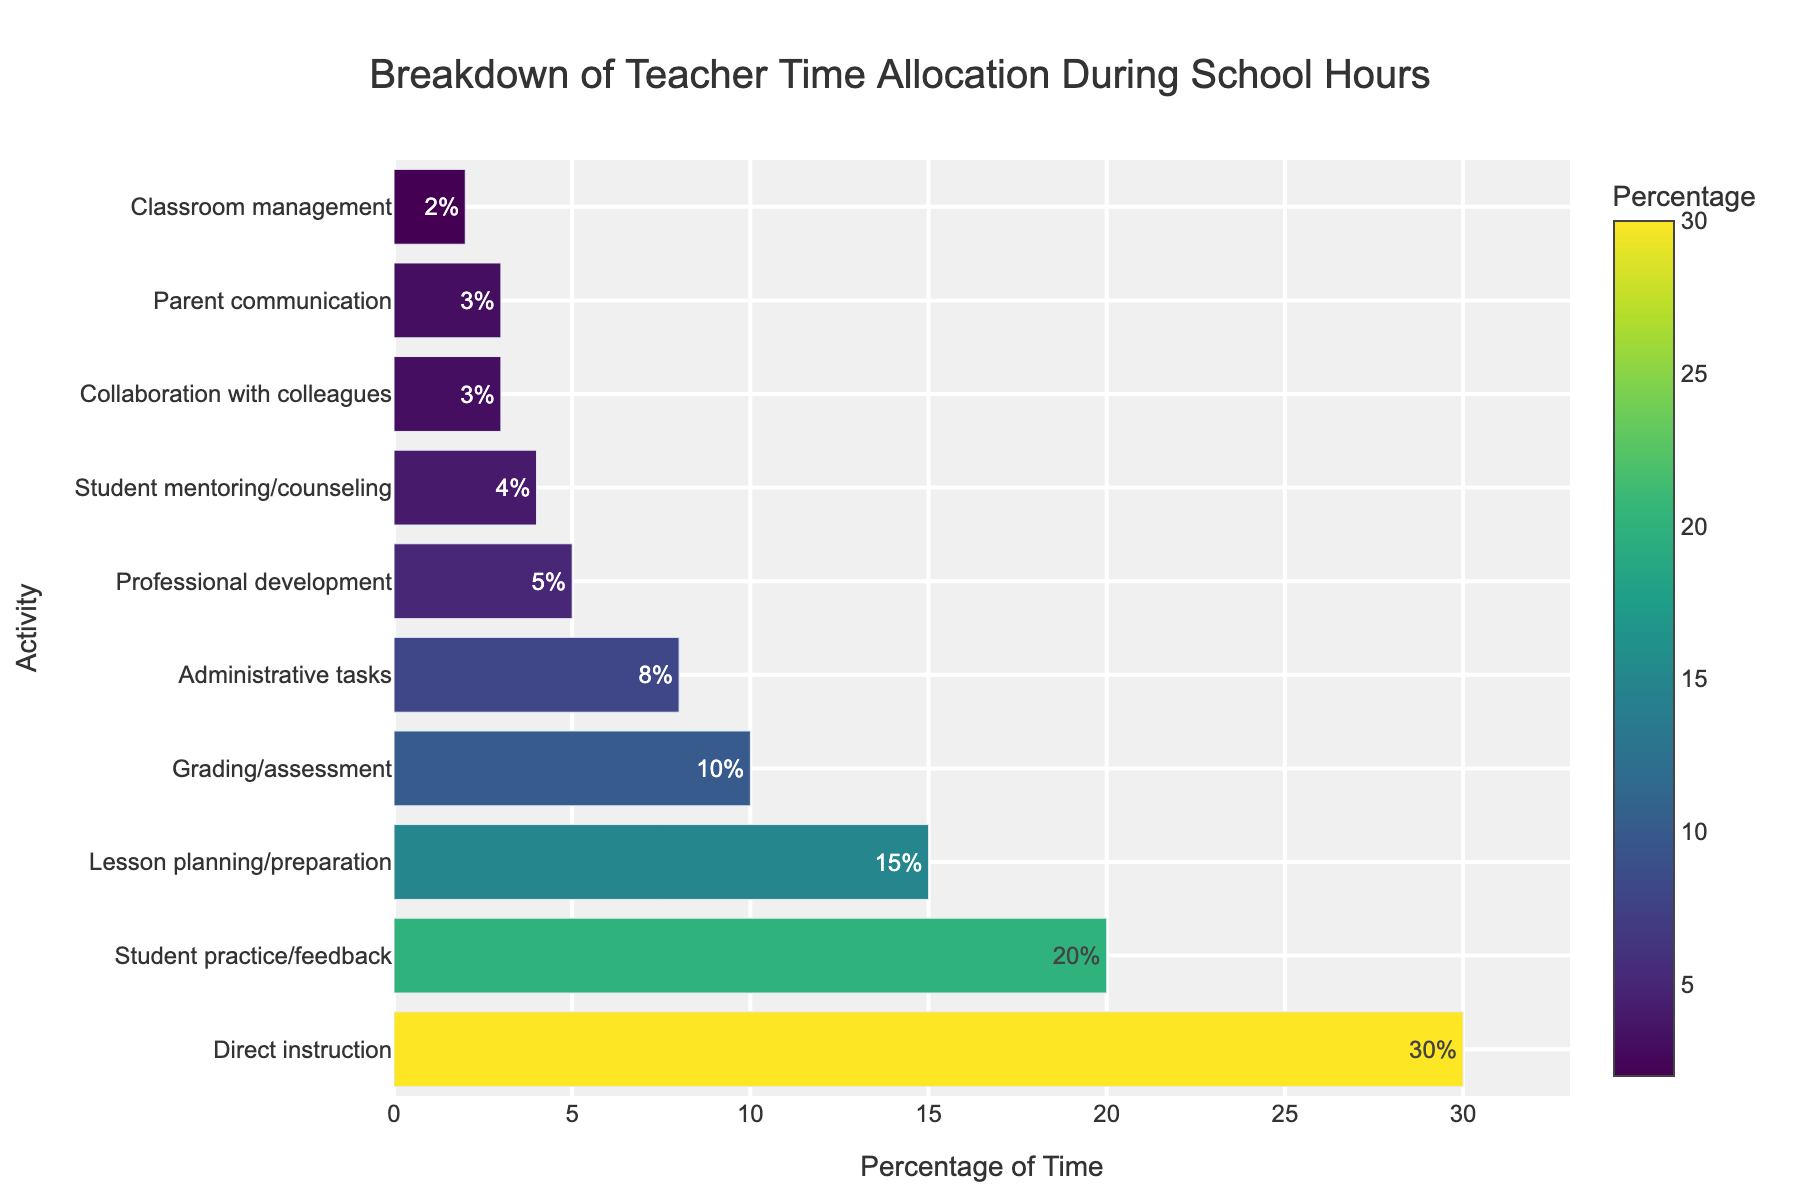What percentage of time is spent on activities directly involved with students (Direct instruction + Student practice/feedback)? The bar chart shows Direct instruction at 30% and Student practice/feedback at 20%. Adding these together, 30% + 20% = 50%.
Answer: 50% What is the difference in time allocation between Lesson planning/preparation and Classroom management? The percentage for Lesson planning/preparation is 15%, and for Classroom management, it is 2%. The difference is 15% - 2% = 13%.
Answer: 13% Which activity type has the highest time allocation, and what is that percentage? The bar chart shows that Direct instruction has the highest time allocation at 30%.
Answer: Direct instruction at 30% How does the time spent on Administrative tasks compare with Professional development? Administrative tasks take 8% of the time, whereas Professional development takes 5%. Administrative tasks take 3% more time than Professional development.
Answer: Administrative tasks take 3% more time Sum the time allocation percentages for activities that are either administrative or indirect support (Administrative tasks, Professional development, Collaboration with colleagues)? Administrative tasks are 8%, Professional development is 5%, and Collaboration with colleagues is 3%. The sum is 8% + 5% + 3% = 16%.
Answer: 16% Which activities each account for less than 5% of the teachers' time? The bar chart shows that Student mentoring/counseling, Collaboration with colleagues, Parent communication, and Classroom management each account for less than 5% of the time.
Answer: Student mentoring/counseling, Collaboration with colleagues, Parent communication, and Classroom management What is the total percentage of time spent on non-instructional activities? (Non-instructional activities include all activities except Direct instruction and Student practice/feedback) Non-instructional activities are Lesson planning/preparation (15%), Grading/assessment (10%), Administrative tasks (8%), Professional development (5%), Student mentoring/counseling (4%), Collaboration with colleagues (3%), Parent communication (3%), and Classroom management (2%). Adding these, 15% + 10% + 8% + 5% + 4% + 3% + 3% + 2% = 50%.
Answer: 50% Which activity has the second smallest time allocation, and what is that percentage? The bar chart shows the second smallest time allocation is for Collaboration with colleagues, at 3%.
Answer: Collaboration with colleagues at 3% How does the combined time for Grading/assessment and Administrative tasks compare with the time spent on Direct instruction? Grading/assessment is 10% and Administrative tasks are 8%, so combined they account for 10% + 8% = 18%. Direct instruction accounts for 30%. Therefore, Direct instruction takes 12% more time than Grading/assessment and Administrative tasks combined.
Answer: Direct instruction takes 12% more time What is the visual difference in length between the bars for Student practice/feedback and Parent communication? The bar for Student practice/feedback is considerably longer and more dominant in color compared to that for Parent communication. Student practice/feedback is 20% while Parent communication is only 3%. Visually, the difference in length of the bars is substantial, making this discrepancy clear.
Answer: Substantial difference in length 